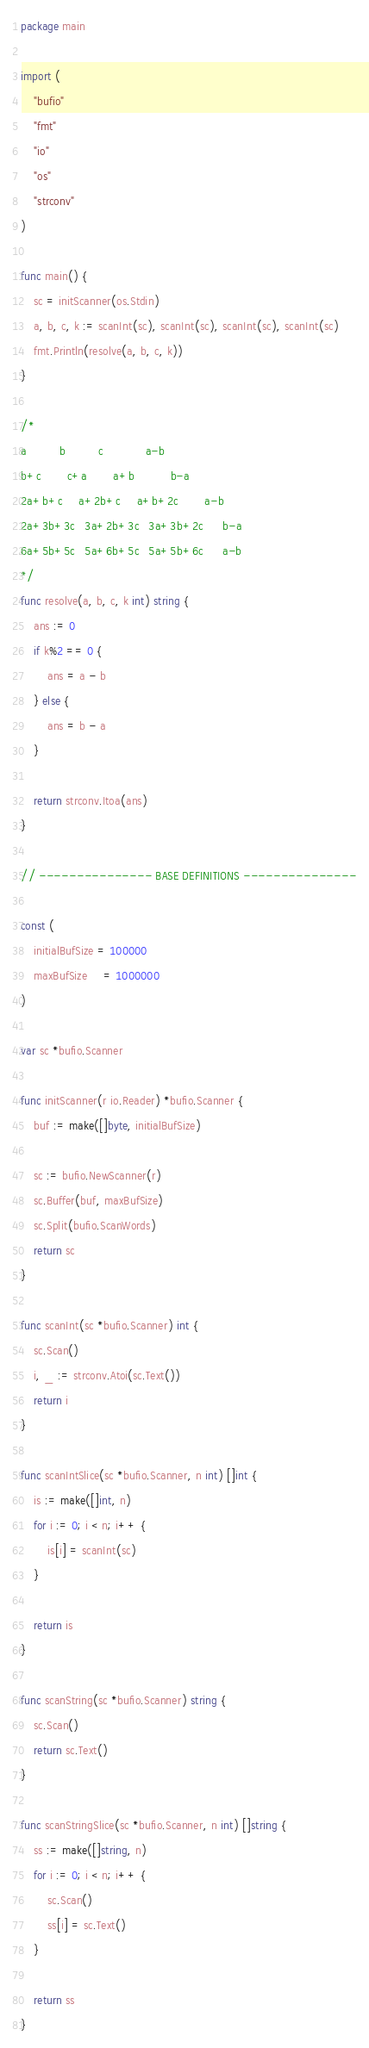<code> <loc_0><loc_0><loc_500><loc_500><_Go_>package main

import (
	"bufio"
	"fmt"
	"io"
	"os"
	"strconv"
)

func main() {
	sc = initScanner(os.Stdin)
	a, b, c, k := scanInt(sc), scanInt(sc), scanInt(sc), scanInt(sc)
	fmt.Println(resolve(a, b, c, k))
}

/*
a          b          c             a-b
b+c        c+a        a+b           b-a
2a+b+c     a+2b+c     a+b+2c        a-b
2a+3b+3c   3a+2b+3c   3a+3b+2c      b-a
6a+5b+5c   5a+6b+5c   5a+5b+6c      a-b
*/
func resolve(a, b, c, k int) string {
	ans := 0
	if k%2 == 0 {
		ans = a - b
	} else {
		ans = b - a
	}

	return strconv.Itoa(ans)
}

// --------------- BASE DEFINITIONS ---------------

const (
	initialBufSize = 100000
	maxBufSize     = 1000000
)

var sc *bufio.Scanner

func initScanner(r io.Reader) *bufio.Scanner {
	buf := make([]byte, initialBufSize)

	sc := bufio.NewScanner(r)
	sc.Buffer(buf, maxBufSize)
	sc.Split(bufio.ScanWords)
	return sc
}

func scanInt(sc *bufio.Scanner) int {
	sc.Scan()
	i, _ := strconv.Atoi(sc.Text())
	return i
}

func scanIntSlice(sc *bufio.Scanner, n int) []int {
	is := make([]int, n)
	for i := 0; i < n; i++ {
		is[i] = scanInt(sc)
	}

	return is
}

func scanString(sc *bufio.Scanner) string {
	sc.Scan()
	return sc.Text()
}

func scanStringSlice(sc *bufio.Scanner, n int) []string {
	ss := make([]string, n)
	for i := 0; i < n; i++ {
		sc.Scan()
		ss[i] = sc.Text()
	}

	return ss
}
</code> 